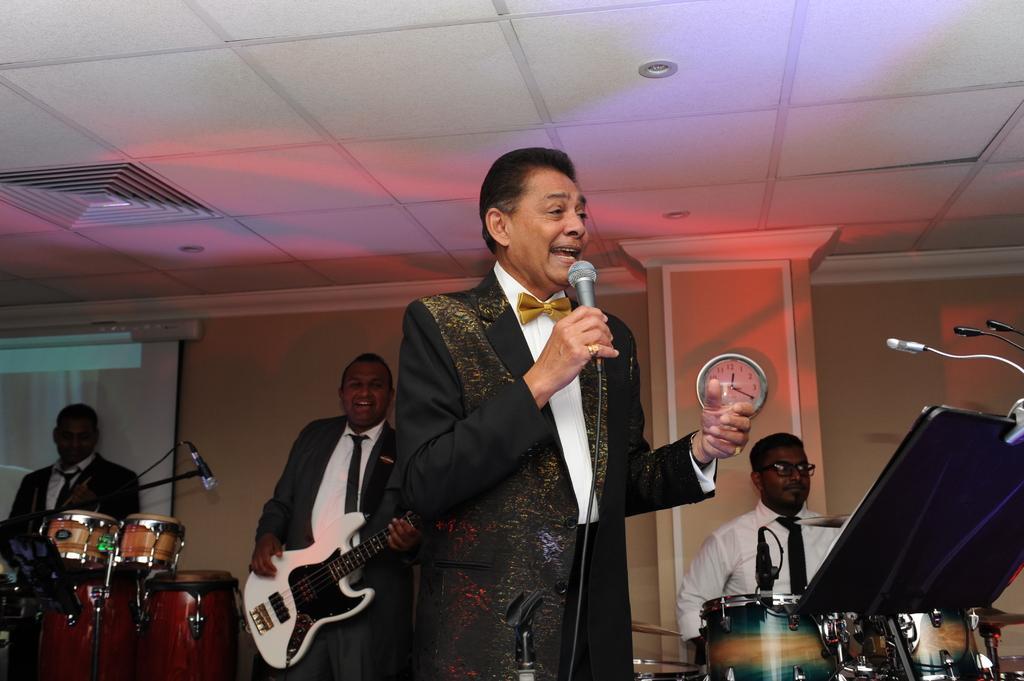In one or two sentences, can you explain what this image depicts? In this picture we can serve man holding mic in his hand and singing and glass in other hand and in background we can see three men playing musical instruments such as drums, guitar and in background we can see wall, watch, pillar. 